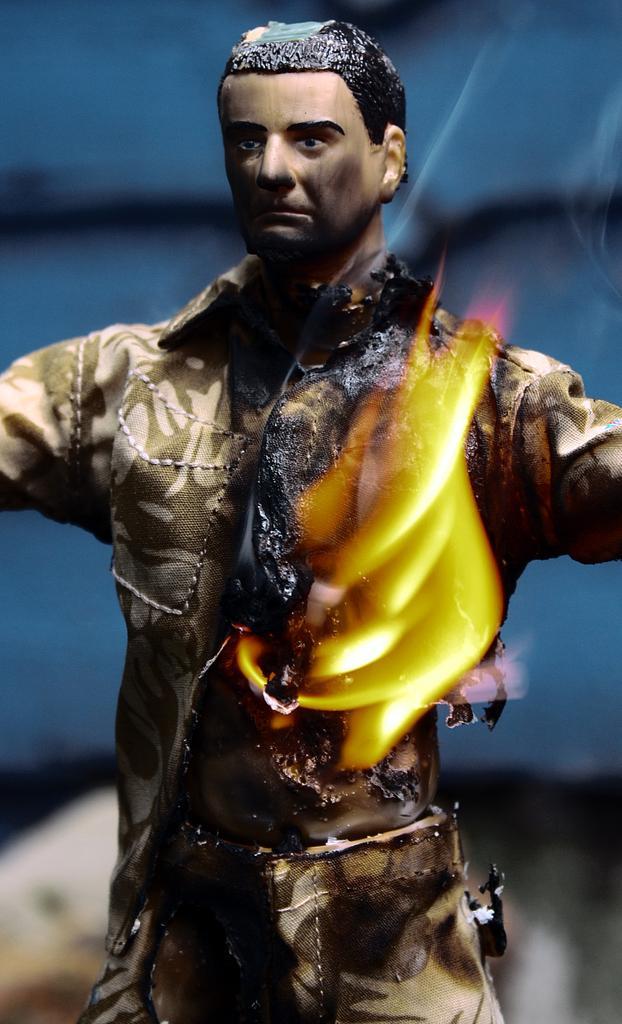Please provide a concise description of this image. In the image we can see a toy of a person wearing clothes. This is a fire and the background is blurred. 